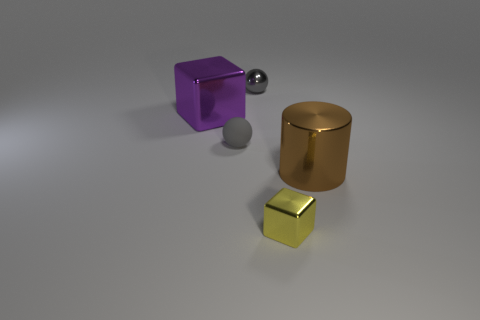There is a small yellow metallic thing; does it have the same shape as the big thing that is in front of the big purple thing?
Make the answer very short. No. What is the small thing that is in front of the tiny gray thing in front of the big metal thing that is on the left side of the brown shiny cylinder made of?
Your response must be concise. Metal. Are there any purple objects of the same size as the gray metal ball?
Make the answer very short. No. What size is the sphere that is made of the same material as the cylinder?
Provide a short and direct response. Small. The large purple thing is what shape?
Provide a succinct answer. Cube. Is the material of the purple thing the same as the sphere in front of the tiny gray shiny thing?
Offer a very short reply. No. What number of things are yellow metal blocks or gray matte balls?
Keep it short and to the point. 2. Are there any tiny cubes?
Provide a succinct answer. Yes. What is the shape of the small metallic object on the left side of the metal thing in front of the shiny cylinder?
Your answer should be compact. Sphere. What number of objects are either yellow shiny blocks that are on the right side of the big block or big things that are behind the brown thing?
Offer a terse response. 2. 